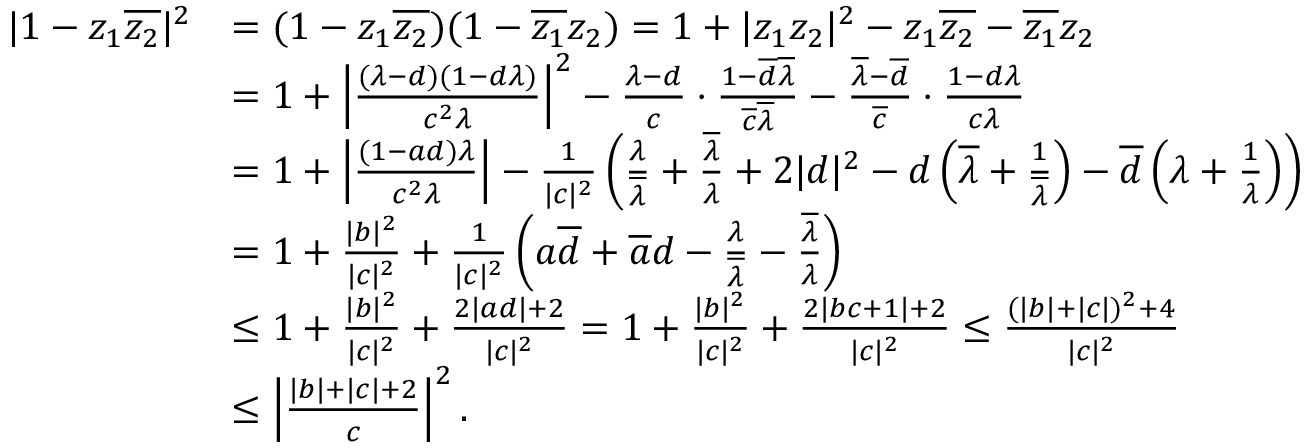<formula> <loc_0><loc_0><loc_500><loc_500>\begin{array} { r l } { | 1 - z _ { 1 } \overline { { z _ { 2 } } } | ^ { 2 } } & { = ( 1 - z _ { 1 } \overline { { z _ { 2 } } } ) ( 1 - \overline { { z _ { 1 } } } z _ { 2 } ) = 1 + | z _ { 1 } z _ { 2 } | ^ { 2 } - z _ { 1 } \overline { { z _ { 2 } } } - \overline { { z _ { 1 } } } z _ { 2 } } \\ & { = 1 + \left | \frac { ( \lambda - d ) ( 1 - d \lambda ) } { c ^ { 2 } \lambda } \right | ^ { 2 } - \frac { \lambda - d } { c } \cdot \frac { 1 - \overline { d } \overline { \lambda } } { \overline { c } \overline { \lambda } } - \frac { \overline { \lambda } - \overline { d } } { \overline { c } } \cdot \frac { 1 - d \lambda } { c \lambda } } \\ & { = 1 + \left | \frac { ( 1 - a d ) \lambda } { c ^ { 2 } \lambda } \right | - \frac { 1 } { | c | ^ { 2 } } \left ( \frac { \lambda } { \overline { \lambda } } + \frac { \overline { \lambda } } { \lambda } + 2 | d | ^ { 2 } - d \left ( \overline { \lambda } + \frac { 1 } { \overline { \lambda } } \right ) - \overline { d } \left ( \lambda + \frac { 1 } { \lambda } \right ) \right ) } \\ & { = 1 + \frac { | b | ^ { 2 } } { | c | ^ { 2 } } + \frac { 1 } { | c | ^ { 2 } } \left ( a \overline { d } + \overline { a } d - \frac { \lambda } { \overline { \lambda } } - \frac { \overline { \lambda } } { \lambda } \right ) } \\ & { \leq 1 + \frac { | b | ^ { 2 } } { | c | ^ { 2 } } + \frac { 2 | a d | + 2 } { | c | ^ { 2 } } = 1 + \frac { | b | ^ { 2 } } { | c | ^ { 2 } } + \frac { 2 | b c + 1 | + 2 } { | c | ^ { 2 } } \leq \frac { ( | b | + | c | ) ^ { 2 } + 4 } { | c | ^ { 2 } } } \\ & { \leq \left | \frac { | b | + | c | + 2 } { c } \right | ^ { 2 } . } \end{array}</formula> 